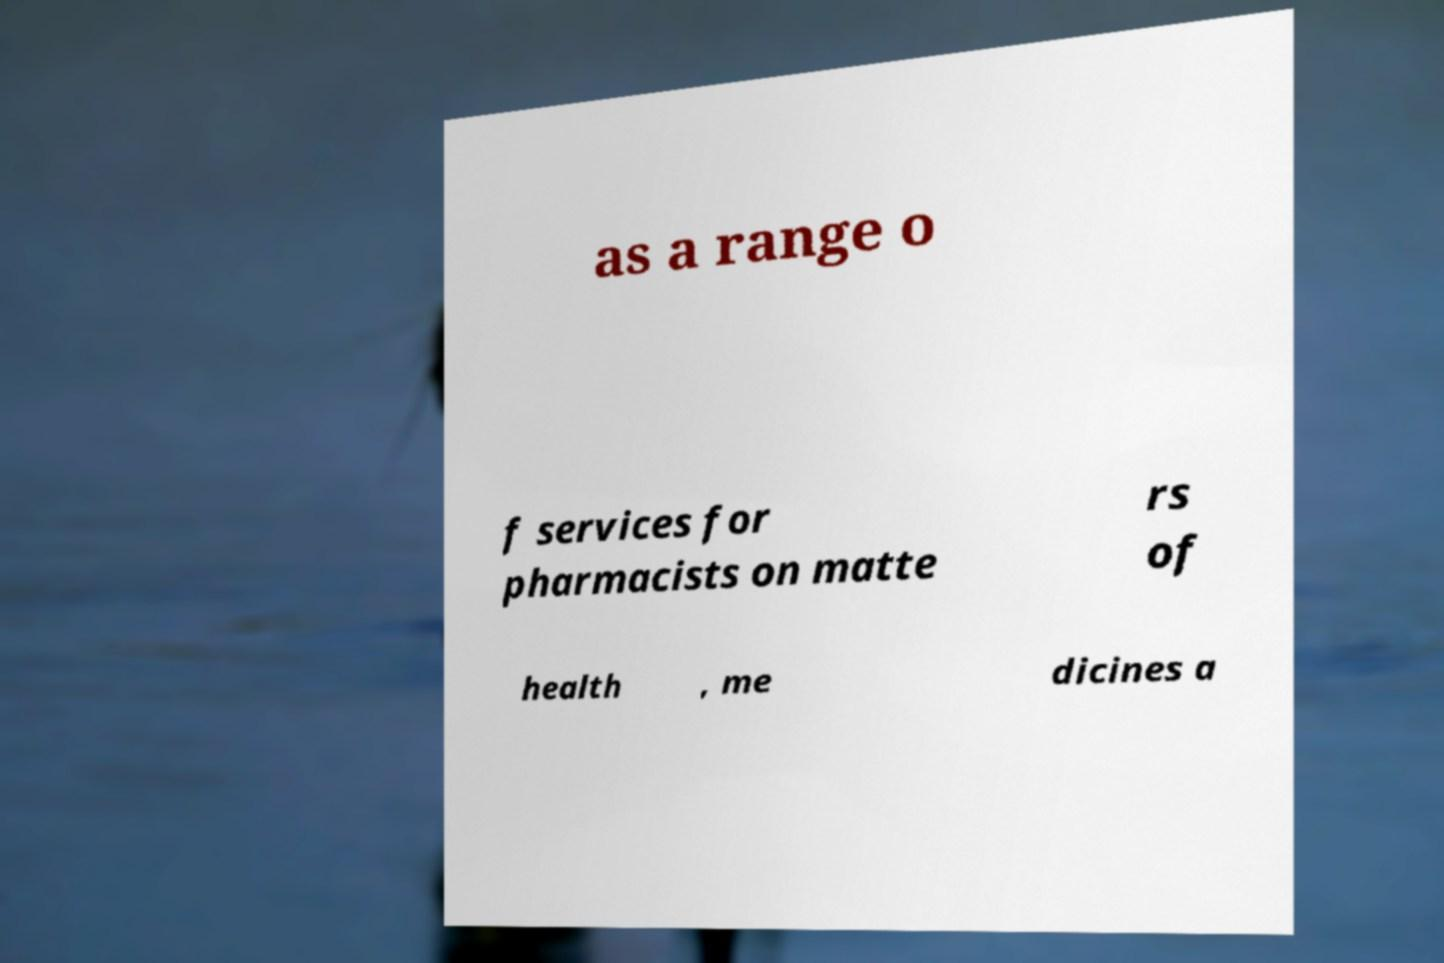Please read and relay the text visible in this image. What does it say? as a range o f services for pharmacists on matte rs of health , me dicines a 